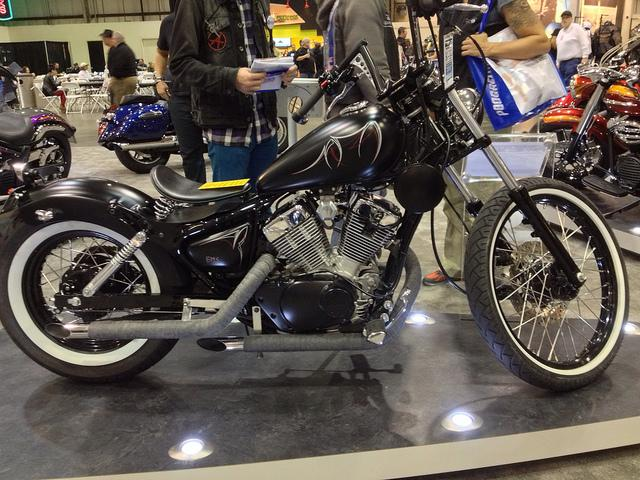What would you call the metal poles connecting to the front wheel? Please explain your reasoning. fork. This looks like tines on this utensil 